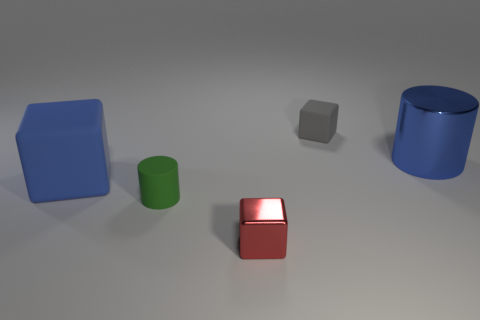The red shiny cube is what size?
Make the answer very short. Small. What number of red blocks have the same size as the green cylinder?
Provide a succinct answer. 1. What number of blue metal things are the same shape as the small gray object?
Offer a very short reply. 0. Are there an equal number of rubber things that are left of the tiny red metallic block and tiny red rubber cylinders?
Make the answer very short. No. Is there any other thing that has the same size as the red cube?
Your answer should be compact. Yes. There is a metal object that is the same size as the rubber cylinder; what shape is it?
Your answer should be compact. Cube. Is there a large brown rubber thing that has the same shape as the tiny gray rubber object?
Your answer should be very brief. No. There is a block to the right of the small cube in front of the blue block; is there a big rubber block that is on the right side of it?
Your answer should be very brief. No. Are there more gray things that are left of the small gray matte object than large cylinders on the right side of the big metal object?
Provide a succinct answer. No. There is a green object that is the same size as the red metal object; what material is it?
Provide a succinct answer. Rubber. 